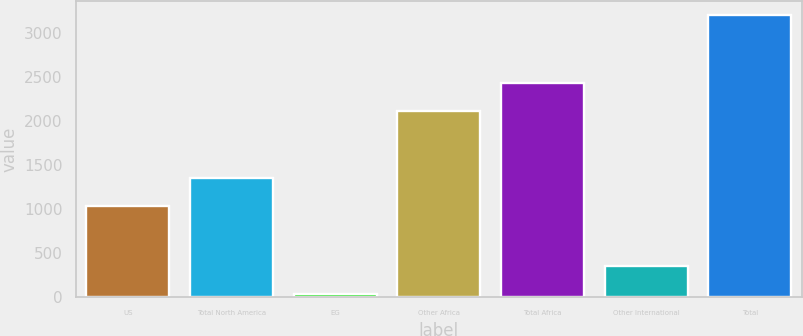Convert chart. <chart><loc_0><loc_0><loc_500><loc_500><bar_chart><fcel>US<fcel>Total North America<fcel>EG<fcel>Other Africa<fcel>Total Africa<fcel>Other International<fcel>Total<nl><fcel>1035<fcel>1352.5<fcel>29<fcel>2108<fcel>2425.5<fcel>346.5<fcel>3204<nl></chart> 